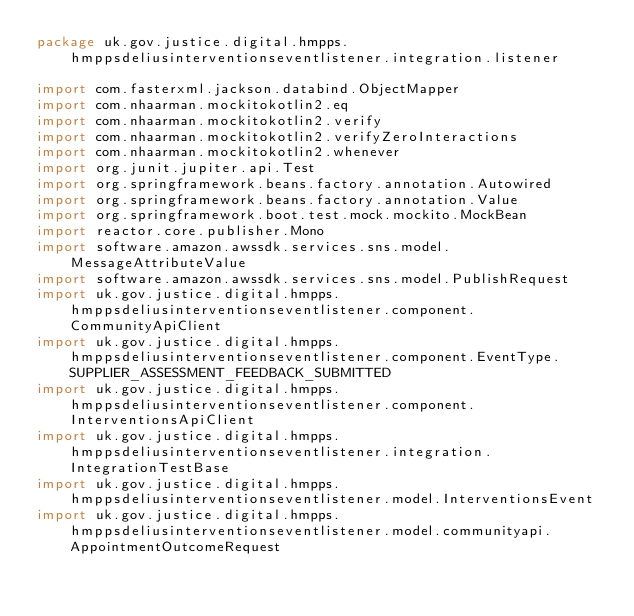Convert code to text. <code><loc_0><loc_0><loc_500><loc_500><_Kotlin_>package uk.gov.justice.digital.hmpps.hmppsdeliusinterventionseventlistener.integration.listener

import com.fasterxml.jackson.databind.ObjectMapper
import com.nhaarman.mockitokotlin2.eq
import com.nhaarman.mockitokotlin2.verify
import com.nhaarman.mockitokotlin2.verifyZeroInteractions
import com.nhaarman.mockitokotlin2.whenever
import org.junit.jupiter.api.Test
import org.springframework.beans.factory.annotation.Autowired
import org.springframework.beans.factory.annotation.Value
import org.springframework.boot.test.mock.mockito.MockBean
import reactor.core.publisher.Mono
import software.amazon.awssdk.services.sns.model.MessageAttributeValue
import software.amazon.awssdk.services.sns.model.PublishRequest
import uk.gov.justice.digital.hmpps.hmppsdeliusinterventionseventlistener.component.CommunityApiClient
import uk.gov.justice.digital.hmpps.hmppsdeliusinterventionseventlistener.component.EventType.SUPPLIER_ASSESSMENT_FEEDBACK_SUBMITTED
import uk.gov.justice.digital.hmpps.hmppsdeliusinterventionseventlistener.component.InterventionsApiClient
import uk.gov.justice.digital.hmpps.hmppsdeliusinterventionseventlistener.integration.IntegrationTestBase
import uk.gov.justice.digital.hmpps.hmppsdeliusinterventionseventlistener.model.InterventionsEvent
import uk.gov.justice.digital.hmpps.hmppsdeliusinterventionseventlistener.model.communityapi.AppointmentOutcomeRequest</code> 